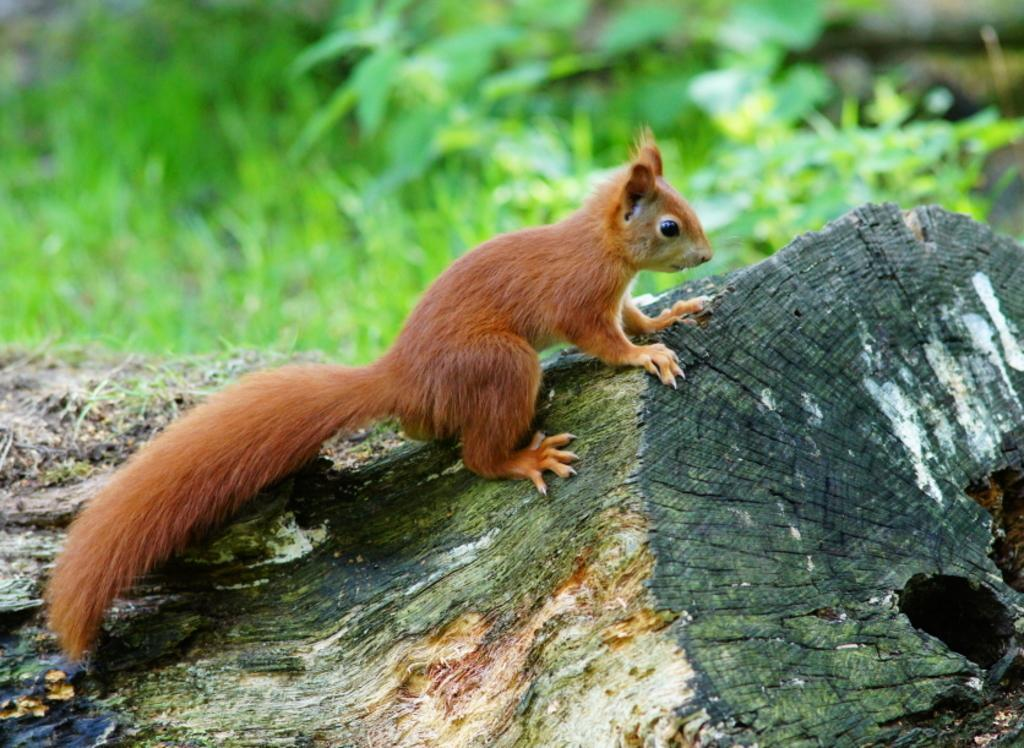Where was the picture taken? The picture was taken outside. What is the main subject in the center of the image? There is an animal in the center of the image. What is the animal standing on? The animal is on a wooden object. What type of vegetation can be seen in the background of the image? There is green grass visible in the background of the image. What else can be seen in the background of the image? There are other objects present in the background of the image. What type of flesh can be seen on the animal's body in the image? There is no flesh visible on the animal's body in the image, as the animal is likely covered in fur or feathers. What type of glass object is present in the image? There is no glass object present in the image. 